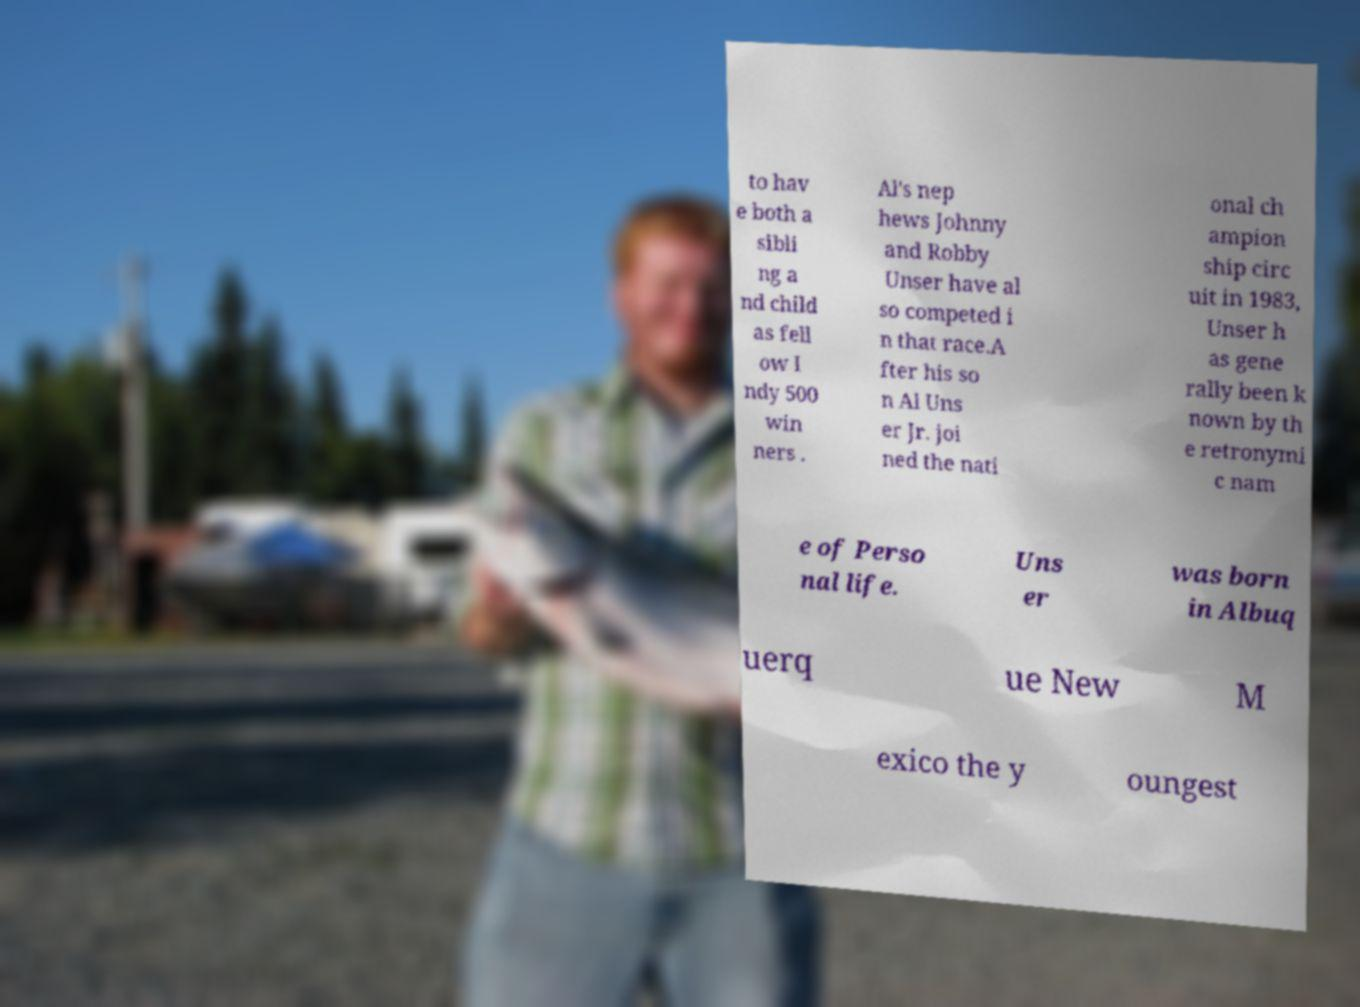There's text embedded in this image that I need extracted. Can you transcribe it verbatim? to hav e both a sibli ng a nd child as fell ow I ndy 500 win ners . Al's nep hews Johnny and Robby Unser have al so competed i n that race.A fter his so n Al Uns er Jr. joi ned the nati onal ch ampion ship circ uit in 1983, Unser h as gene rally been k nown by th e retronymi c nam e of Perso nal life. Uns er was born in Albuq uerq ue New M exico the y oungest 